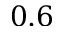<formula> <loc_0><loc_0><loc_500><loc_500>0 . 6</formula> 